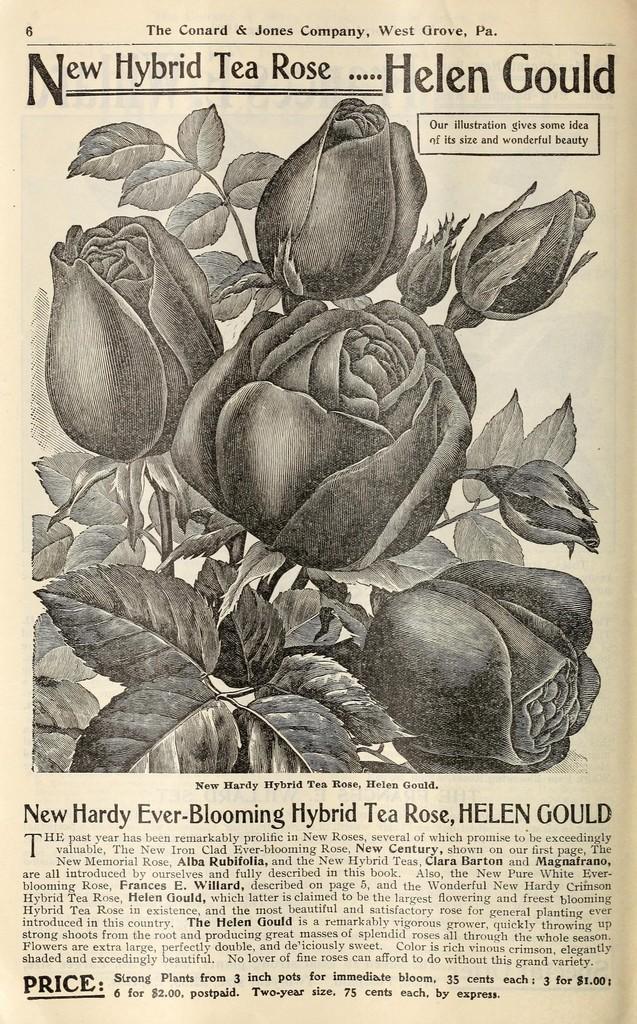Please provide a concise description of this image. In this image I can see few roses, few leaves and something is written on the paper with black color. 